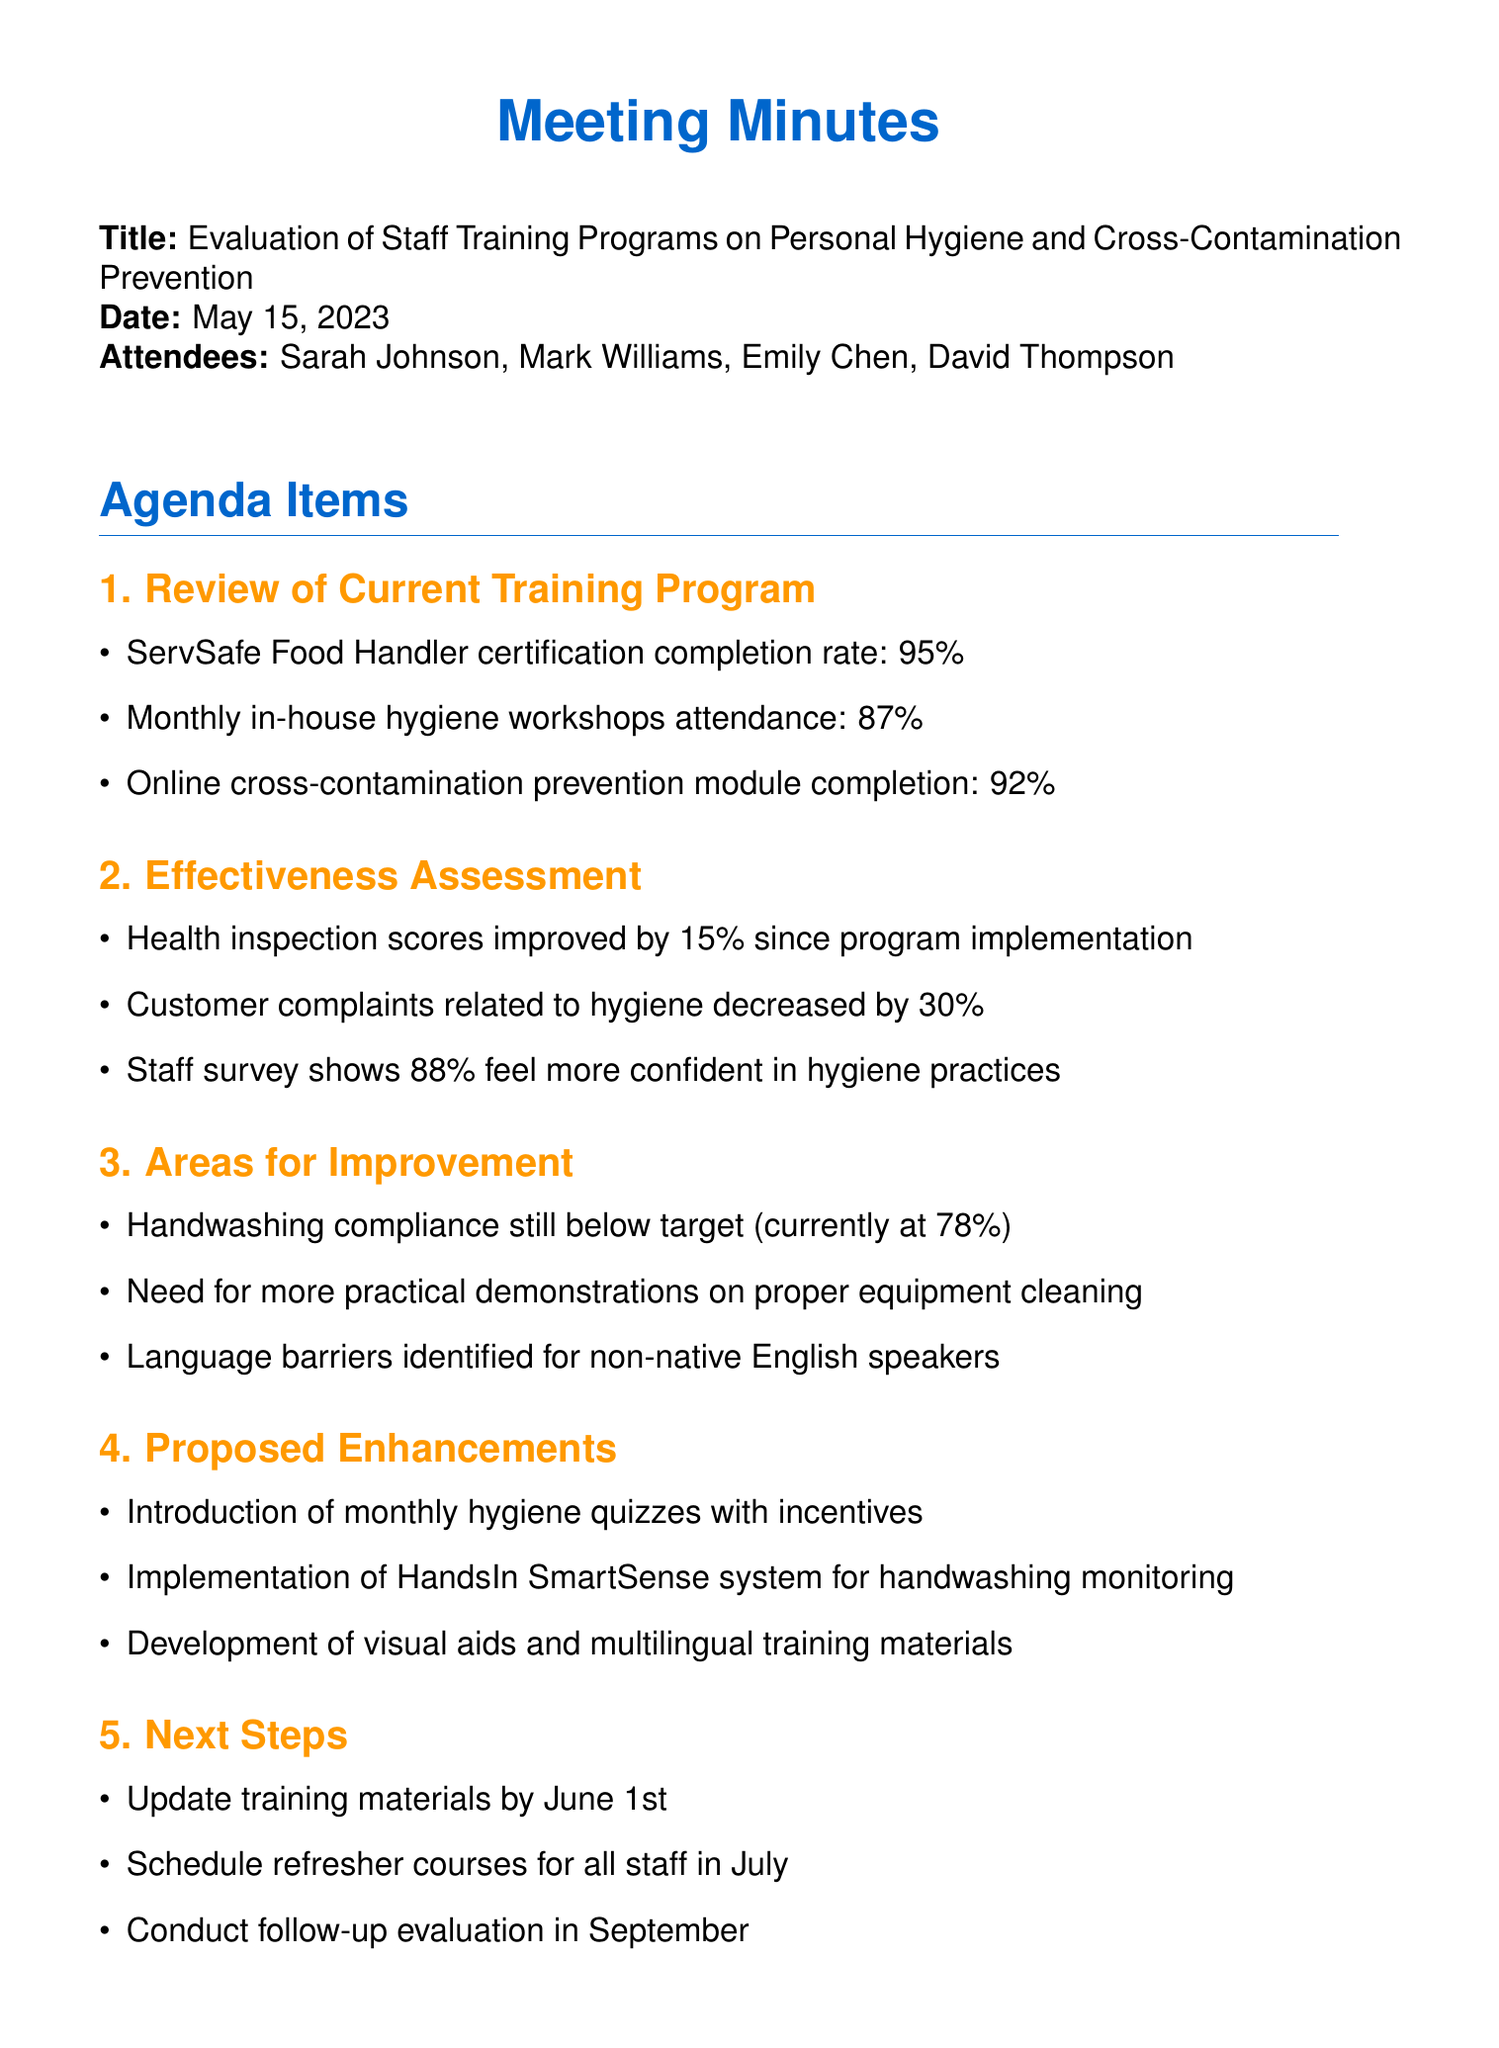What is the completion rate for the ServSafe Food Handler certification? The completion rate for the ServSafe Food Handler certification is mentioned in the document under the review of the current training program.
Answer: 95% What percentage of health inspection scores improved since program implementation? The document states the improvement in health inspection scores during the effectiveness assessment section.
Answer: 15% Who is responsible for creating multilingual training videos? The action items section specifies who is assigned each task, including the task of creating multilingual training videos.
Answer: David Thompson What is the current handwashing compliance rate? The document provides the current handwashing compliance rate under areas for improvement.
Answer: 78% What date is the deadline for purchasing the HandsIn SmartSense system? The document outlines the deadlines for each task in the action items section, including this purchase.
Answer: June 15, 2023 How many attendees were present at the meeting? The list of attendees at the beginning of the document gives the total count of individuals present.
Answer: 4 What is one proposed enhancement to the training program? The proposed enhancements section lists several suggested improvements for the training program.
Answer: Introduction of monthly hygiene quizzes with incentives What is the next scheduled evaluation date? The next steps section indicates the timeline for future evaluations mentioned in the document.
Answer: September 